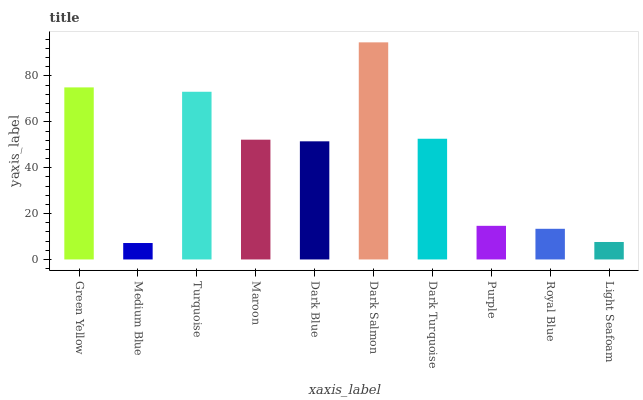Is Turquoise the minimum?
Answer yes or no. No. Is Turquoise the maximum?
Answer yes or no. No. Is Turquoise greater than Medium Blue?
Answer yes or no. Yes. Is Medium Blue less than Turquoise?
Answer yes or no. Yes. Is Medium Blue greater than Turquoise?
Answer yes or no. No. Is Turquoise less than Medium Blue?
Answer yes or no. No. Is Maroon the high median?
Answer yes or no. Yes. Is Dark Blue the low median?
Answer yes or no. Yes. Is Medium Blue the high median?
Answer yes or no. No. Is Light Seafoam the low median?
Answer yes or no. No. 